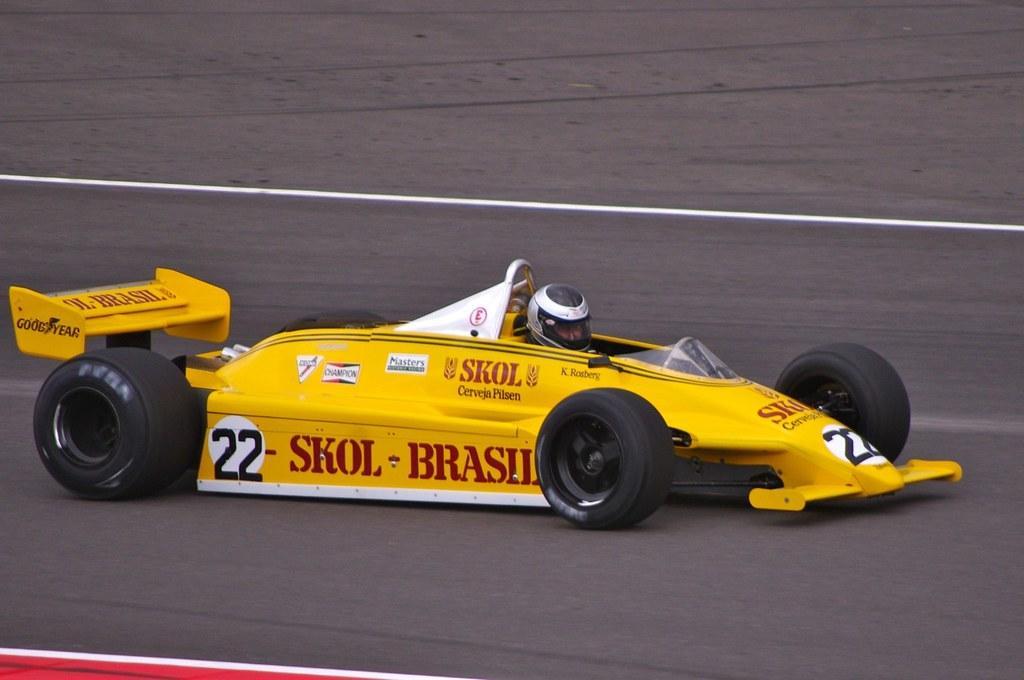Can you describe this image briefly? In this image we can see a vehicle and a person. In the background of the image there is a road. At the bottom of the image there is an object. 